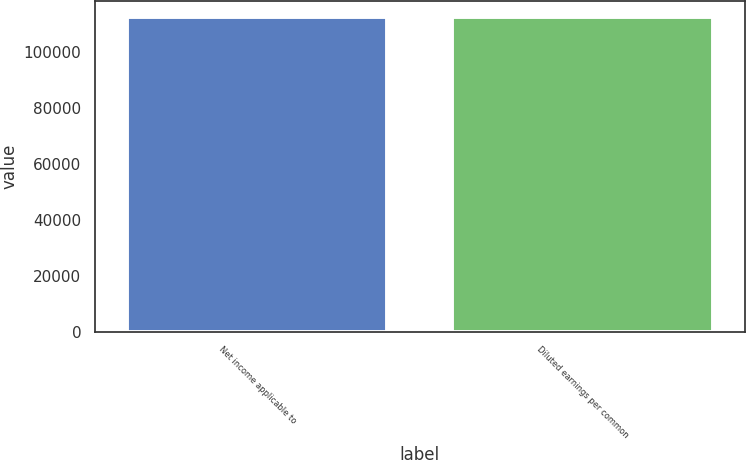Convert chart to OTSL. <chart><loc_0><loc_0><loc_500><loc_500><bar_chart><fcel>Net income applicable to<fcel>Diluted earnings per common<nl><fcel>112480<fcel>112480<nl></chart> 